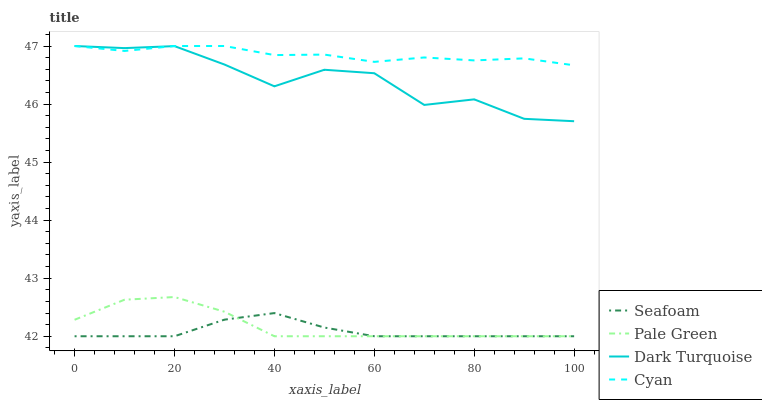Does Seafoam have the minimum area under the curve?
Answer yes or no. Yes. Does Cyan have the maximum area under the curve?
Answer yes or no. Yes. Does Pale Green have the minimum area under the curve?
Answer yes or no. No. Does Pale Green have the maximum area under the curve?
Answer yes or no. No. Is Seafoam the smoothest?
Answer yes or no. Yes. Is Dark Turquoise the roughest?
Answer yes or no. Yes. Is Pale Green the smoothest?
Answer yes or no. No. Is Pale Green the roughest?
Answer yes or no. No. Does Pale Green have the lowest value?
Answer yes or no. Yes. Does Cyan have the lowest value?
Answer yes or no. No. Does Cyan have the highest value?
Answer yes or no. Yes. Does Pale Green have the highest value?
Answer yes or no. No. Is Seafoam less than Cyan?
Answer yes or no. Yes. Is Dark Turquoise greater than Seafoam?
Answer yes or no. Yes. Does Seafoam intersect Pale Green?
Answer yes or no. Yes. Is Seafoam less than Pale Green?
Answer yes or no. No. Is Seafoam greater than Pale Green?
Answer yes or no. No. Does Seafoam intersect Cyan?
Answer yes or no. No. 